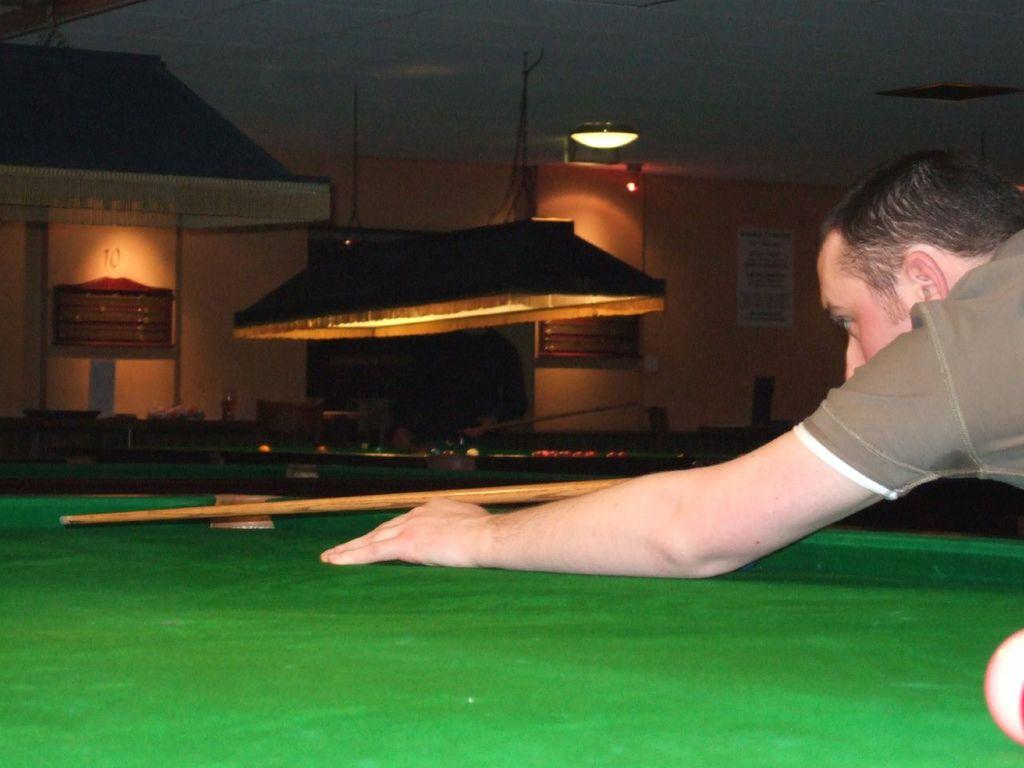What is the main object in the image? There is a snooker board in the image. Can you describe the person in the image? The person is holding a cue and aiming with it. What is the person using to play the game? The person is using a cue to play the game. What else can be seen in the image? There are lights present in the image. Can you tell me how many tigers are present in the image? There are no tigers present in the image. What type of board is the fireman using to slide down in the image? There is no fireman or sliding board present in the image. 